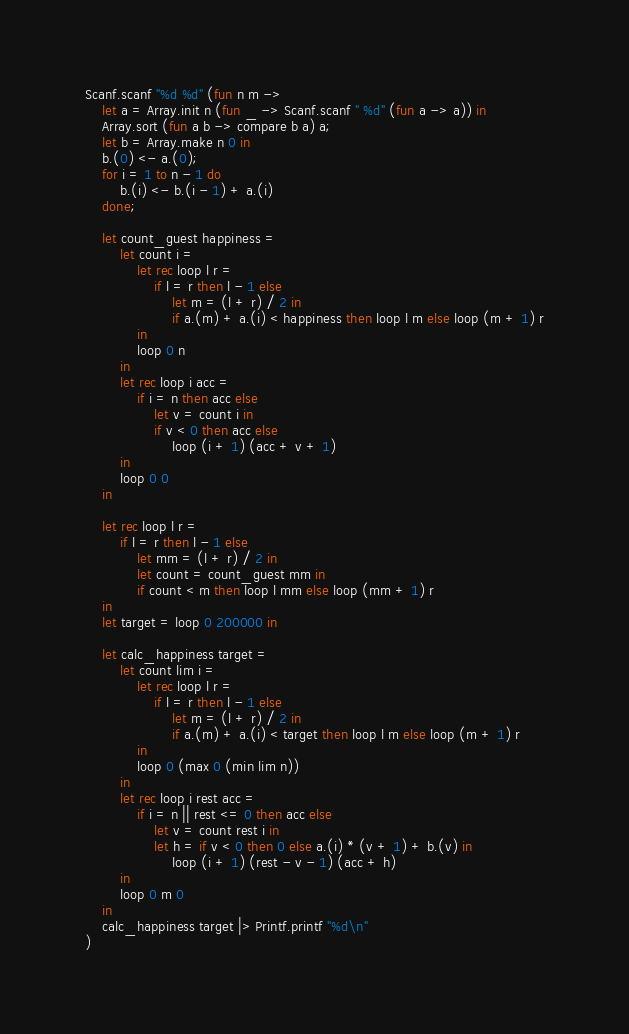<code> <loc_0><loc_0><loc_500><loc_500><_OCaml_>Scanf.scanf "%d %d" (fun n m ->
    let a = Array.init n (fun _ -> Scanf.scanf " %d" (fun a -> a)) in
    Array.sort (fun a b -> compare b a) a;
    let b = Array.make n 0 in
    b.(0) <- a.(0);
    for i = 1 to n - 1 do
        b.(i) <- b.(i - 1) + a.(i)
    done;

    let count_guest happiness =
        let count i =
            let rec loop l r =
                if l = r then l - 1 else
                    let m = (l + r) / 2 in
                    if a.(m) + a.(i) < happiness then loop l m else loop (m + 1) r
            in
            loop 0 n
        in
        let rec loop i acc =
            if i = n then acc else
                let v = count i in
                if v < 0 then acc else
                    loop (i + 1) (acc + v + 1)
        in
        loop 0 0
    in

    let rec loop l r =
        if l = r then l - 1 else
            let mm = (l + r) / 2 in
            let count = count_guest mm in
            if count < m then loop l mm else loop (mm + 1) r
    in
    let target = loop 0 200000 in

    let calc_happiness target =
        let count lim i =
            let rec loop l r =
                if l = r then l - 1 else
                    let m = (l + r) / 2 in
                    if a.(m) + a.(i) < target then loop l m else loop (m + 1) r
            in
            loop 0 (max 0 (min lim n))
        in
        let rec loop i rest acc =
            if i = n || rest <= 0 then acc else
                let v = count rest i in
                let h = if v < 0 then 0 else a.(i) * (v + 1) + b.(v) in
                    loop (i + 1) (rest - v - 1) (acc + h)
        in
        loop 0 m 0
    in
    calc_happiness target |> Printf.printf "%d\n"
)</code> 